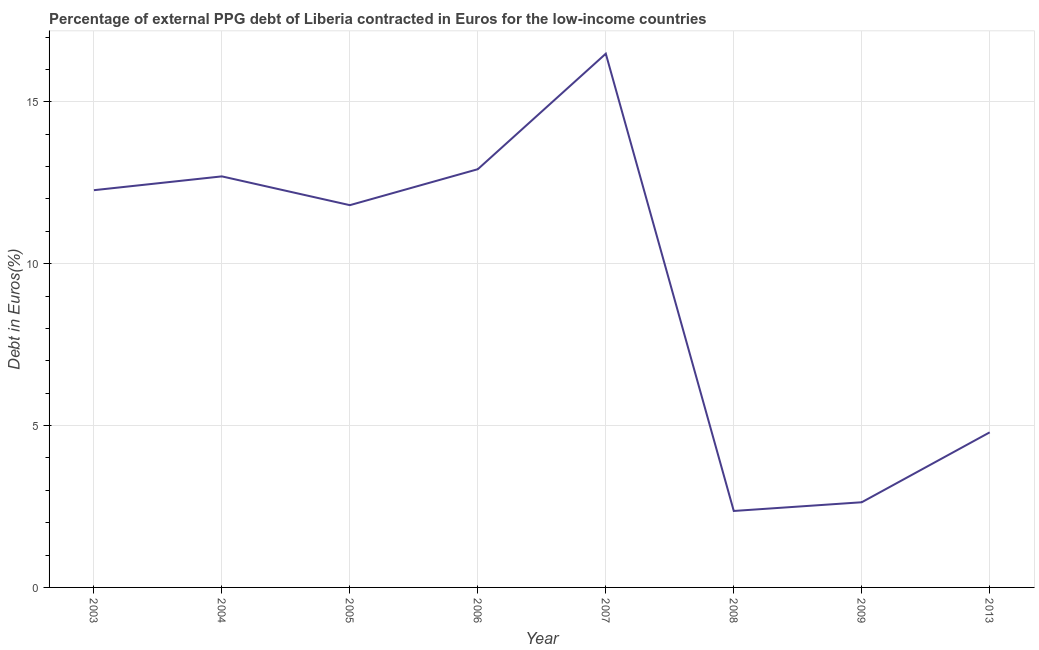What is the currency composition of ppg debt in 2005?
Your answer should be compact. 11.81. Across all years, what is the maximum currency composition of ppg debt?
Offer a terse response. 16.49. Across all years, what is the minimum currency composition of ppg debt?
Offer a terse response. 2.36. In which year was the currency composition of ppg debt maximum?
Offer a very short reply. 2007. What is the sum of the currency composition of ppg debt?
Your response must be concise. 75.97. What is the difference between the currency composition of ppg debt in 2004 and 2006?
Offer a terse response. -0.22. What is the average currency composition of ppg debt per year?
Keep it short and to the point. 9.5. What is the median currency composition of ppg debt?
Ensure brevity in your answer.  12.04. Do a majority of the years between 2006 and 2003 (inclusive) have currency composition of ppg debt greater than 3 %?
Make the answer very short. Yes. What is the ratio of the currency composition of ppg debt in 2008 to that in 2009?
Your response must be concise. 0.9. What is the difference between the highest and the second highest currency composition of ppg debt?
Your answer should be compact. 3.57. Is the sum of the currency composition of ppg debt in 2003 and 2013 greater than the maximum currency composition of ppg debt across all years?
Your answer should be very brief. Yes. What is the difference between the highest and the lowest currency composition of ppg debt?
Offer a very short reply. 14.13. Does the currency composition of ppg debt monotonically increase over the years?
Keep it short and to the point. No. How many years are there in the graph?
Ensure brevity in your answer.  8. What is the difference between two consecutive major ticks on the Y-axis?
Your answer should be compact. 5. Are the values on the major ticks of Y-axis written in scientific E-notation?
Your answer should be compact. No. Does the graph contain any zero values?
Your response must be concise. No. What is the title of the graph?
Ensure brevity in your answer.  Percentage of external PPG debt of Liberia contracted in Euros for the low-income countries. What is the label or title of the Y-axis?
Give a very brief answer. Debt in Euros(%). What is the Debt in Euros(%) of 2003?
Your answer should be compact. 12.27. What is the Debt in Euros(%) of 2004?
Your answer should be compact. 12.7. What is the Debt in Euros(%) in 2005?
Offer a terse response. 11.81. What is the Debt in Euros(%) of 2006?
Offer a very short reply. 12.92. What is the Debt in Euros(%) in 2007?
Offer a terse response. 16.49. What is the Debt in Euros(%) of 2008?
Keep it short and to the point. 2.36. What is the Debt in Euros(%) in 2009?
Your answer should be compact. 2.63. What is the Debt in Euros(%) in 2013?
Give a very brief answer. 4.79. What is the difference between the Debt in Euros(%) in 2003 and 2004?
Your answer should be compact. -0.43. What is the difference between the Debt in Euros(%) in 2003 and 2005?
Provide a succinct answer. 0.46. What is the difference between the Debt in Euros(%) in 2003 and 2006?
Provide a short and direct response. -0.65. What is the difference between the Debt in Euros(%) in 2003 and 2007?
Provide a succinct answer. -4.22. What is the difference between the Debt in Euros(%) in 2003 and 2008?
Provide a short and direct response. 9.91. What is the difference between the Debt in Euros(%) in 2003 and 2009?
Your response must be concise. 9.64. What is the difference between the Debt in Euros(%) in 2003 and 2013?
Make the answer very short. 7.48. What is the difference between the Debt in Euros(%) in 2004 and 2005?
Your answer should be very brief. 0.89. What is the difference between the Debt in Euros(%) in 2004 and 2006?
Provide a succinct answer. -0.22. What is the difference between the Debt in Euros(%) in 2004 and 2007?
Offer a terse response. -3.79. What is the difference between the Debt in Euros(%) in 2004 and 2008?
Your answer should be very brief. 10.34. What is the difference between the Debt in Euros(%) in 2004 and 2009?
Provide a short and direct response. 10.07. What is the difference between the Debt in Euros(%) in 2004 and 2013?
Offer a terse response. 7.91. What is the difference between the Debt in Euros(%) in 2005 and 2006?
Offer a very short reply. -1.11. What is the difference between the Debt in Euros(%) in 2005 and 2007?
Offer a terse response. -4.68. What is the difference between the Debt in Euros(%) in 2005 and 2008?
Make the answer very short. 9.45. What is the difference between the Debt in Euros(%) in 2005 and 2009?
Your answer should be very brief. 9.18. What is the difference between the Debt in Euros(%) in 2005 and 2013?
Offer a very short reply. 7.02. What is the difference between the Debt in Euros(%) in 2006 and 2007?
Keep it short and to the point. -3.57. What is the difference between the Debt in Euros(%) in 2006 and 2008?
Your answer should be compact. 10.56. What is the difference between the Debt in Euros(%) in 2006 and 2009?
Your response must be concise. 10.29. What is the difference between the Debt in Euros(%) in 2006 and 2013?
Offer a very short reply. 8.13. What is the difference between the Debt in Euros(%) in 2007 and 2008?
Provide a short and direct response. 14.13. What is the difference between the Debt in Euros(%) in 2007 and 2009?
Your response must be concise. 13.86. What is the difference between the Debt in Euros(%) in 2007 and 2013?
Give a very brief answer. 11.7. What is the difference between the Debt in Euros(%) in 2008 and 2009?
Offer a very short reply. -0.27. What is the difference between the Debt in Euros(%) in 2008 and 2013?
Offer a terse response. -2.43. What is the difference between the Debt in Euros(%) in 2009 and 2013?
Provide a succinct answer. -2.16. What is the ratio of the Debt in Euros(%) in 2003 to that in 2004?
Provide a short and direct response. 0.97. What is the ratio of the Debt in Euros(%) in 2003 to that in 2005?
Offer a terse response. 1.04. What is the ratio of the Debt in Euros(%) in 2003 to that in 2007?
Give a very brief answer. 0.74. What is the ratio of the Debt in Euros(%) in 2003 to that in 2008?
Keep it short and to the point. 5.2. What is the ratio of the Debt in Euros(%) in 2003 to that in 2009?
Your answer should be very brief. 4.66. What is the ratio of the Debt in Euros(%) in 2003 to that in 2013?
Provide a succinct answer. 2.56. What is the ratio of the Debt in Euros(%) in 2004 to that in 2005?
Your answer should be compact. 1.07. What is the ratio of the Debt in Euros(%) in 2004 to that in 2006?
Give a very brief answer. 0.98. What is the ratio of the Debt in Euros(%) in 2004 to that in 2007?
Your answer should be very brief. 0.77. What is the ratio of the Debt in Euros(%) in 2004 to that in 2008?
Your answer should be very brief. 5.38. What is the ratio of the Debt in Euros(%) in 2004 to that in 2009?
Your answer should be compact. 4.83. What is the ratio of the Debt in Euros(%) in 2004 to that in 2013?
Your answer should be very brief. 2.65. What is the ratio of the Debt in Euros(%) in 2005 to that in 2006?
Offer a terse response. 0.91. What is the ratio of the Debt in Euros(%) in 2005 to that in 2007?
Make the answer very short. 0.72. What is the ratio of the Debt in Euros(%) in 2005 to that in 2008?
Your response must be concise. 5. What is the ratio of the Debt in Euros(%) in 2005 to that in 2009?
Make the answer very short. 4.49. What is the ratio of the Debt in Euros(%) in 2005 to that in 2013?
Offer a very short reply. 2.46. What is the ratio of the Debt in Euros(%) in 2006 to that in 2007?
Provide a short and direct response. 0.78. What is the ratio of the Debt in Euros(%) in 2006 to that in 2008?
Offer a very short reply. 5.47. What is the ratio of the Debt in Euros(%) in 2006 to that in 2009?
Provide a succinct answer. 4.91. What is the ratio of the Debt in Euros(%) in 2006 to that in 2013?
Make the answer very short. 2.7. What is the ratio of the Debt in Euros(%) in 2007 to that in 2008?
Make the answer very short. 6.98. What is the ratio of the Debt in Euros(%) in 2007 to that in 2009?
Your answer should be very brief. 6.27. What is the ratio of the Debt in Euros(%) in 2007 to that in 2013?
Give a very brief answer. 3.44. What is the ratio of the Debt in Euros(%) in 2008 to that in 2009?
Ensure brevity in your answer.  0.9. What is the ratio of the Debt in Euros(%) in 2008 to that in 2013?
Ensure brevity in your answer.  0.49. What is the ratio of the Debt in Euros(%) in 2009 to that in 2013?
Your answer should be compact. 0.55. 